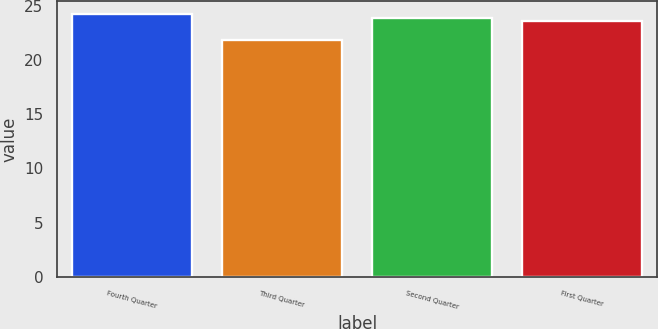Convert chart to OTSL. <chart><loc_0><loc_0><loc_500><loc_500><bar_chart><fcel>Fourth Quarter<fcel>Third Quarter<fcel>Second Quarter<fcel>First Quarter<nl><fcel>24.24<fcel>21.9<fcel>23.86<fcel>23.63<nl></chart> 